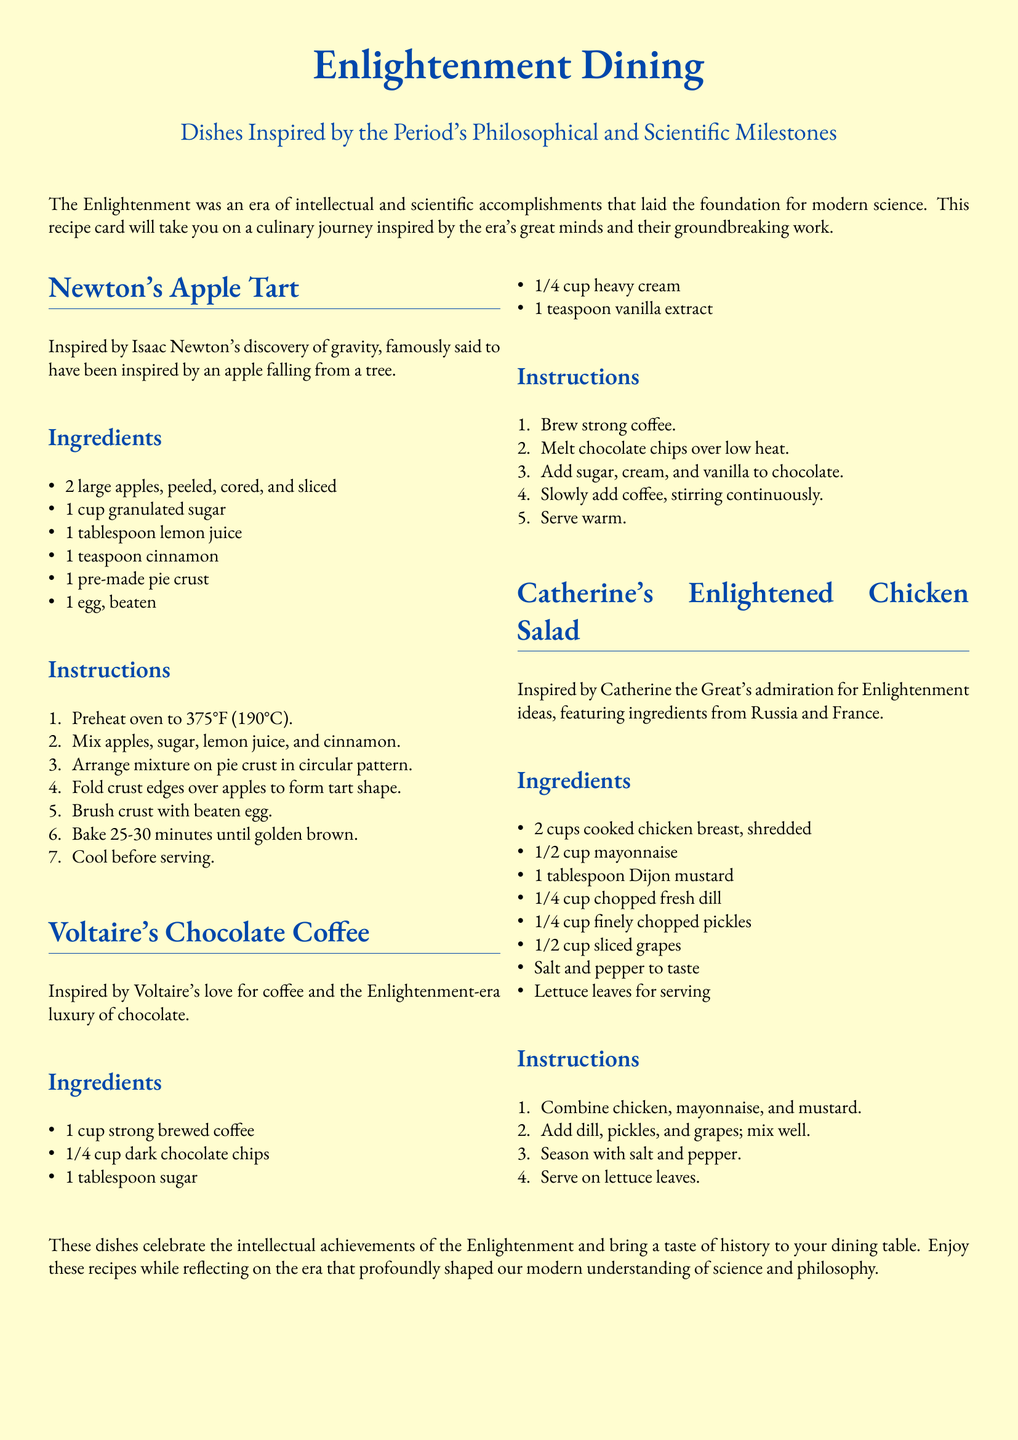What is the title of the document? The title is prominently displayed at the top of the document.
Answer: Enlightenment Dining Who is the author of Newton's Apple Tart? This dish is inspired by a famous scientist mentioned in the document.
Answer: Isaac Newton What temperature should the oven be preheated to for the apple tart? The document specifies the temperature for the apple tart in the instructions.
Answer: 375°F What ingredient is used in Voltaire's Chocolate Coffee to sweeten it? This information is found in the ingredients list for Voltaire's recipe.
Answer: Sugar How many cups of cooked chicken are needed for Catherine's salad? This quantity is specified in the ingredients for Catherine's Chicken Salad.
Answer: 2 cups What type of leaves are suggested for serving the chicken salad? This detail is mentioned in the serving instructions for the salad.
Answer: Lettuce leaves What is the main flavoring ingredient in Catherine's chicken salad besides mayonnaise? The document lists additional flavoring ingredients in the recipe.
Answer: Dijon mustard What is the primary beverage in Voltaire's recipe? The recipe's title gives a clear indication of the main beverage used.
Answer: Coffee 